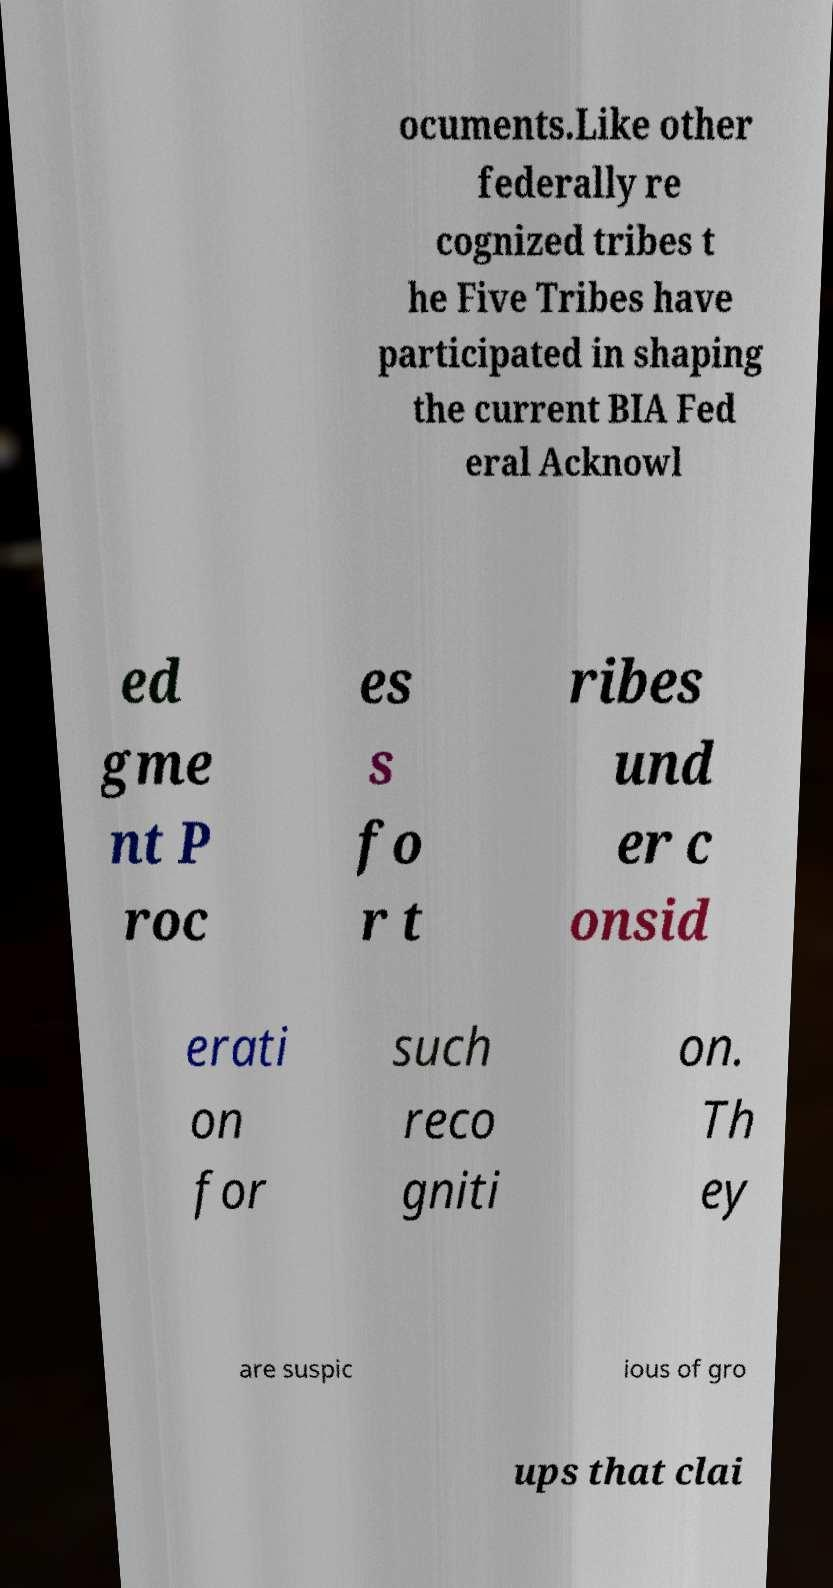Please identify and transcribe the text found in this image. ocuments.Like other federally re cognized tribes t he Five Tribes have participated in shaping the current BIA Fed eral Acknowl ed gme nt P roc es s fo r t ribes und er c onsid erati on for such reco gniti on. Th ey are suspic ious of gro ups that clai 